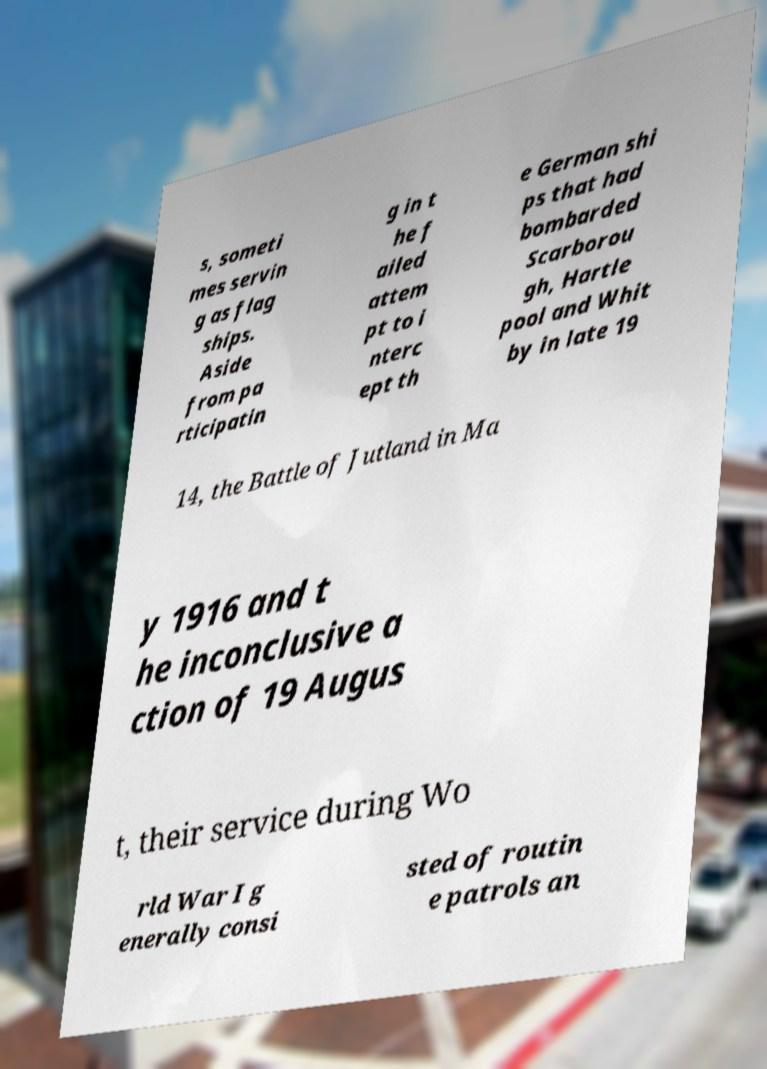Could you extract and type out the text from this image? s, someti mes servin g as flag ships. Aside from pa rticipatin g in t he f ailed attem pt to i nterc ept th e German shi ps that had bombarded Scarborou gh, Hartle pool and Whit by in late 19 14, the Battle of Jutland in Ma y 1916 and t he inconclusive a ction of 19 Augus t, their service during Wo rld War I g enerally consi sted of routin e patrols an 